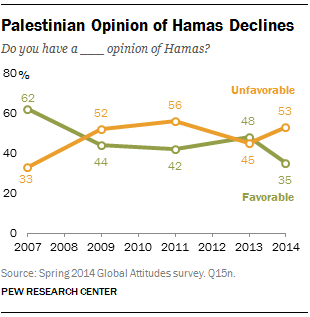Outline some significant characteristics in this image. The given graph shows a line that is colored green. The opinion indicated by the green line is favorable. In the year 2014, it was the dominant opinion that was unfavorable. 